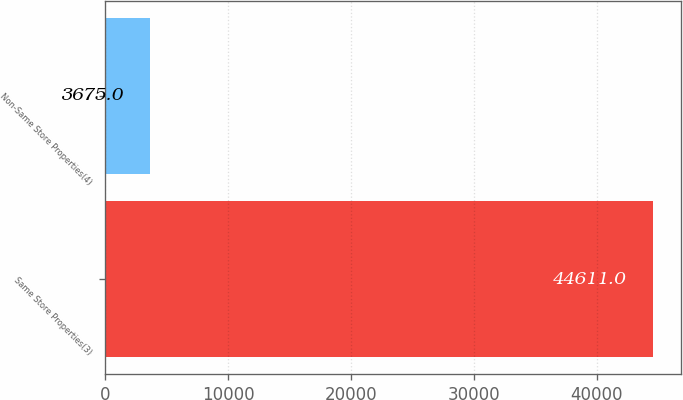Convert chart to OTSL. <chart><loc_0><loc_0><loc_500><loc_500><bar_chart><fcel>Same Store Properties(3)<fcel>Non-Same Store Properties(4)<nl><fcel>44611<fcel>3675<nl></chart> 